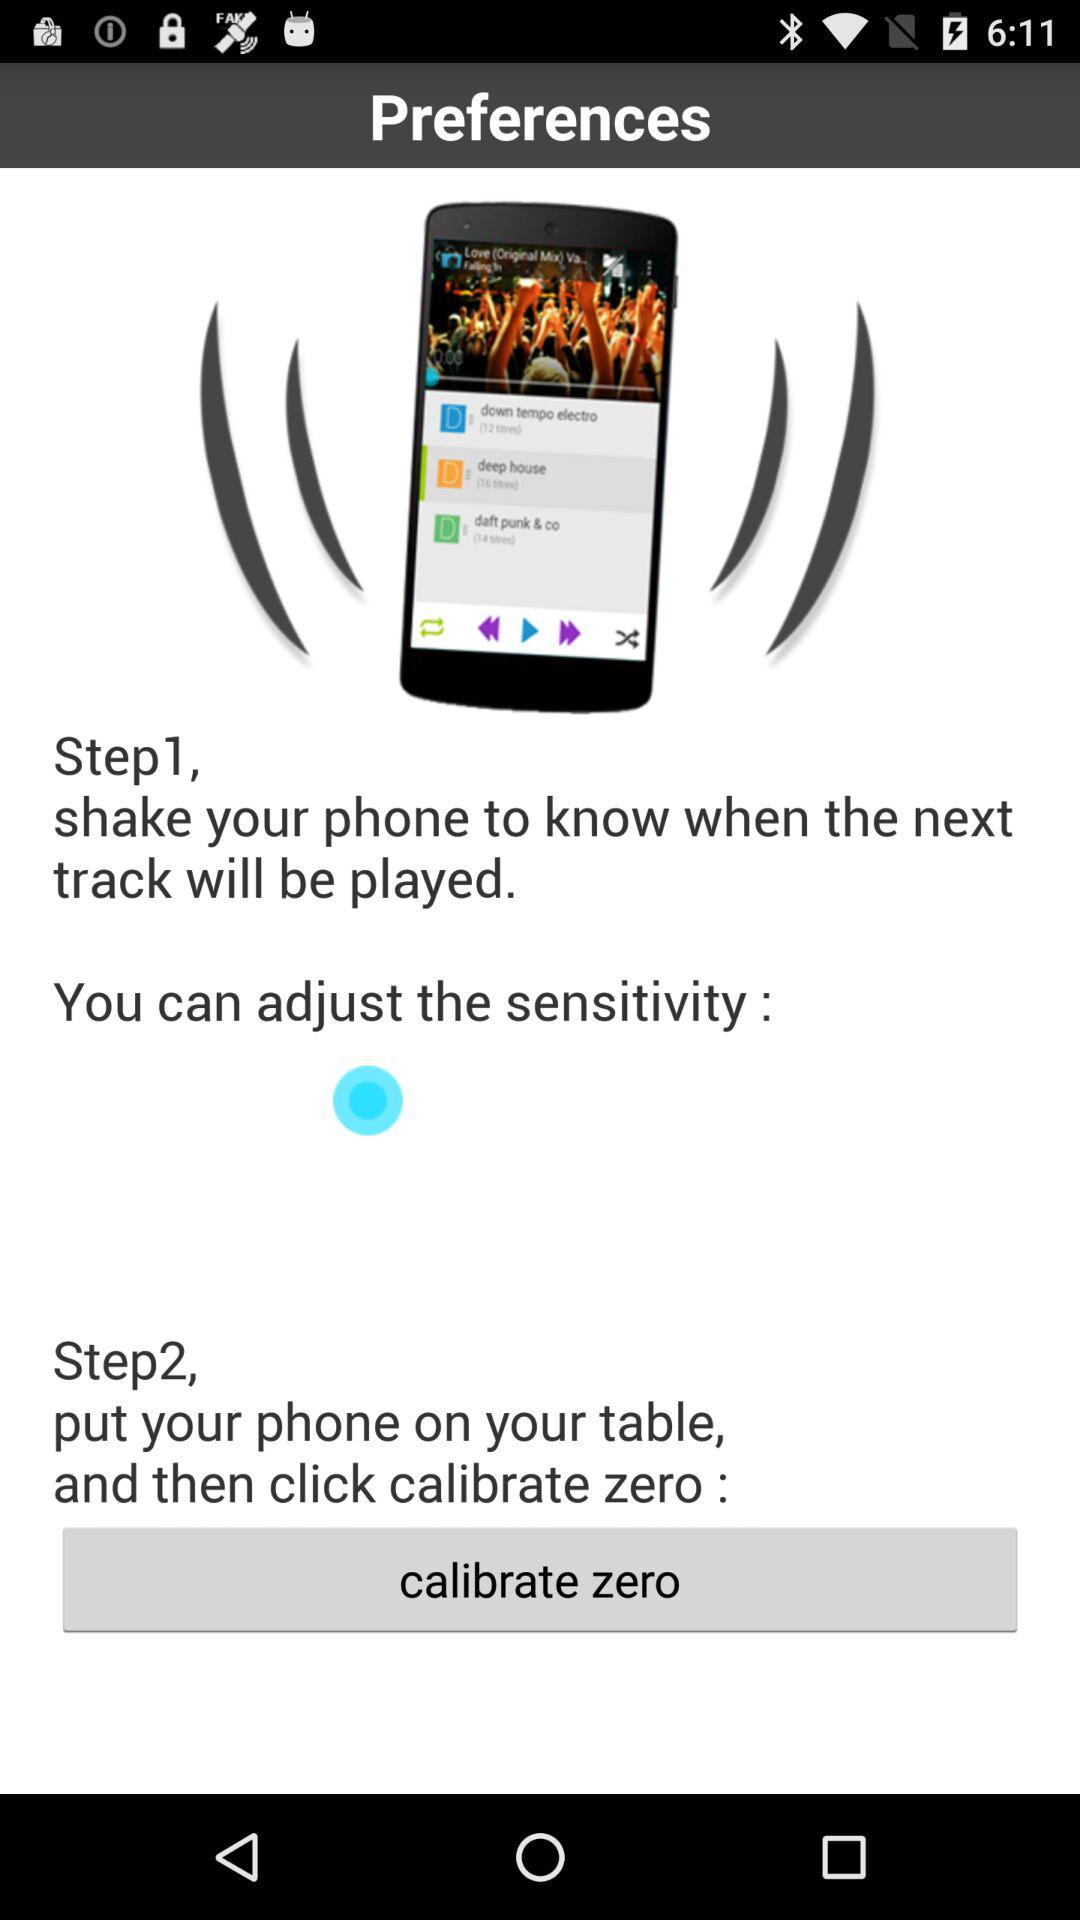What is step 1? Step 1 is "shake your phone to know when the next track will be played.". 